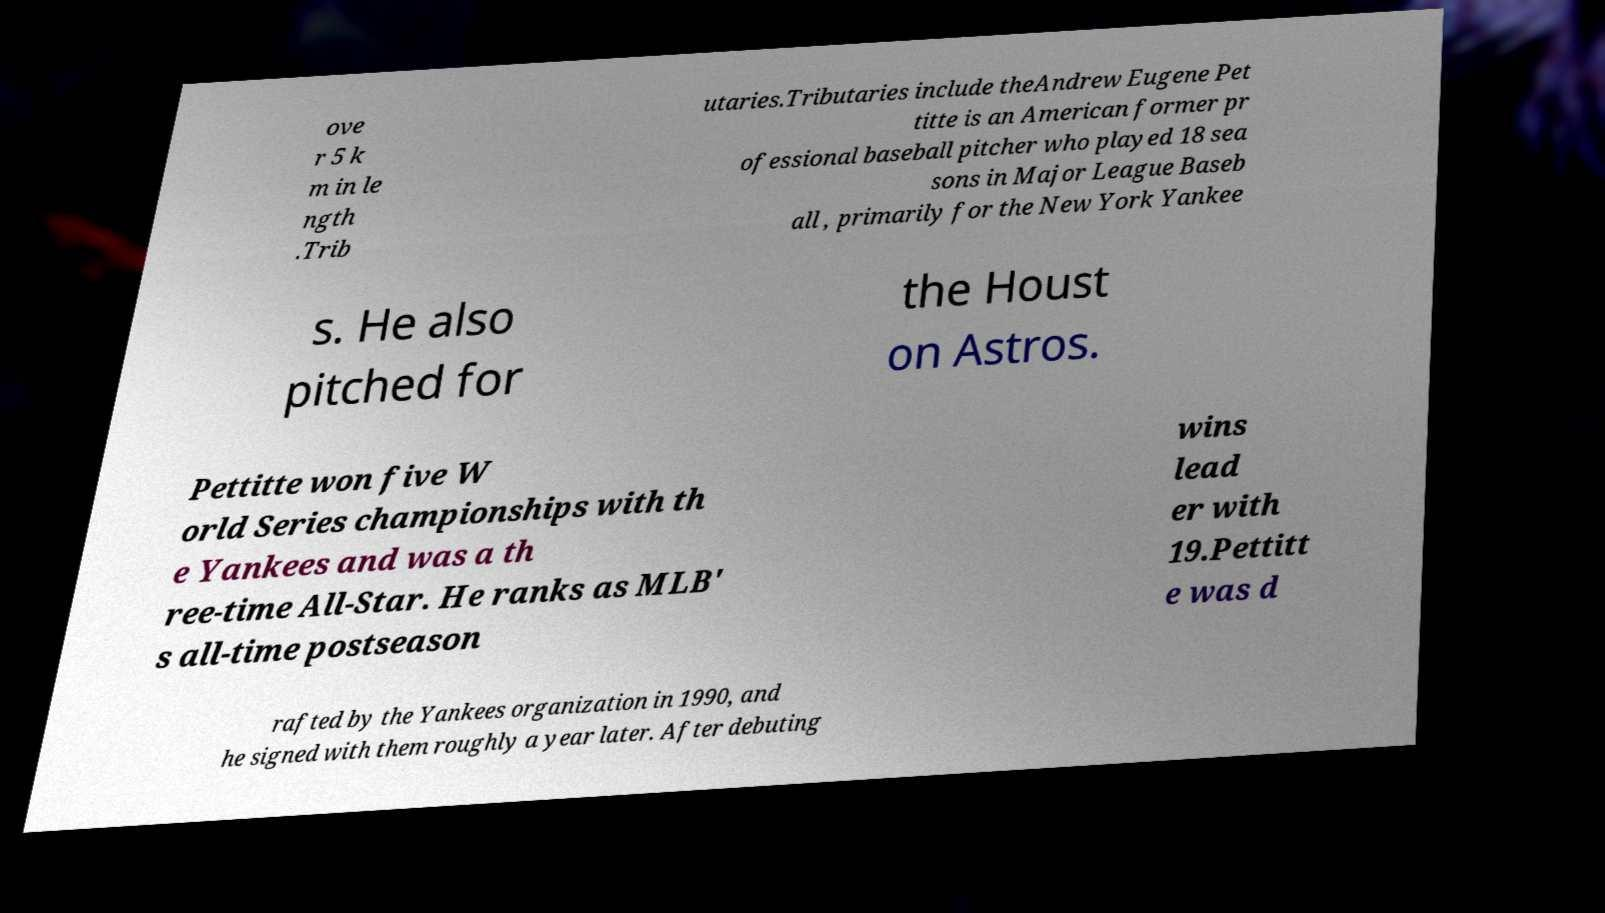Could you extract and type out the text from this image? ove r 5 k m in le ngth .Trib utaries.Tributaries include theAndrew Eugene Pet titte is an American former pr ofessional baseball pitcher who played 18 sea sons in Major League Baseb all , primarily for the New York Yankee s. He also pitched for the Houst on Astros. Pettitte won five W orld Series championships with th e Yankees and was a th ree-time All-Star. He ranks as MLB' s all-time postseason wins lead er with 19.Pettitt e was d rafted by the Yankees organization in 1990, and he signed with them roughly a year later. After debuting 